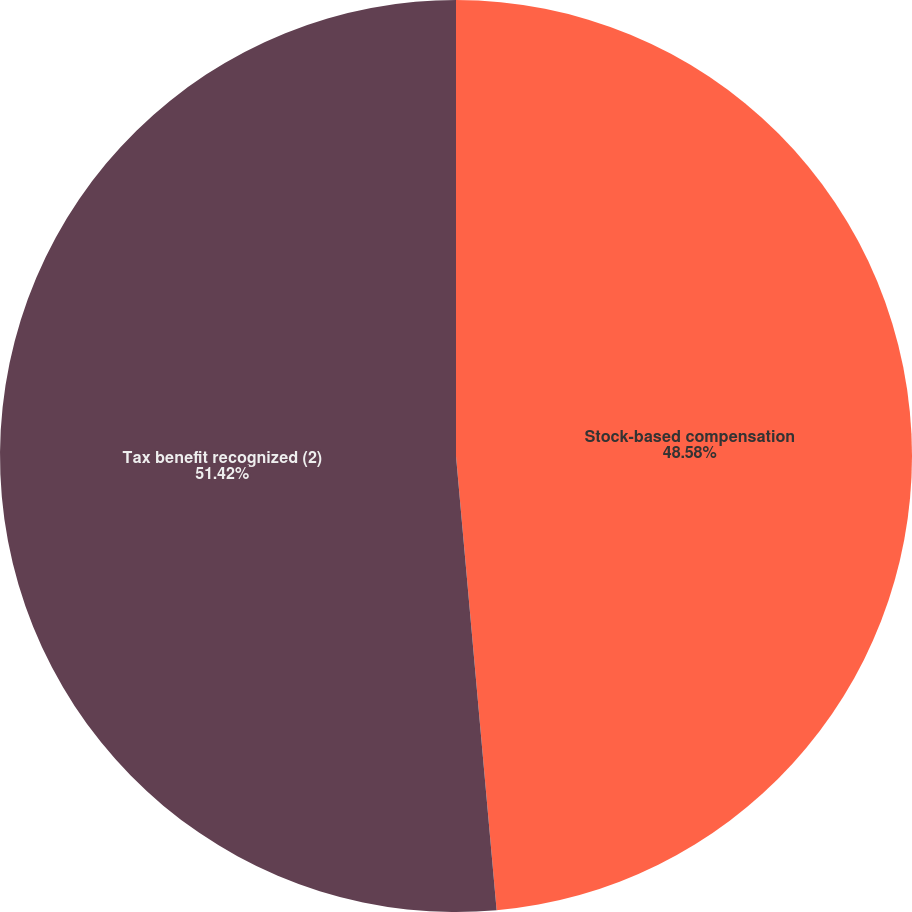Convert chart to OTSL. <chart><loc_0><loc_0><loc_500><loc_500><pie_chart><fcel>Stock-based compensation<fcel>Tax benefit recognized (2)<nl><fcel>48.58%<fcel>51.42%<nl></chart> 